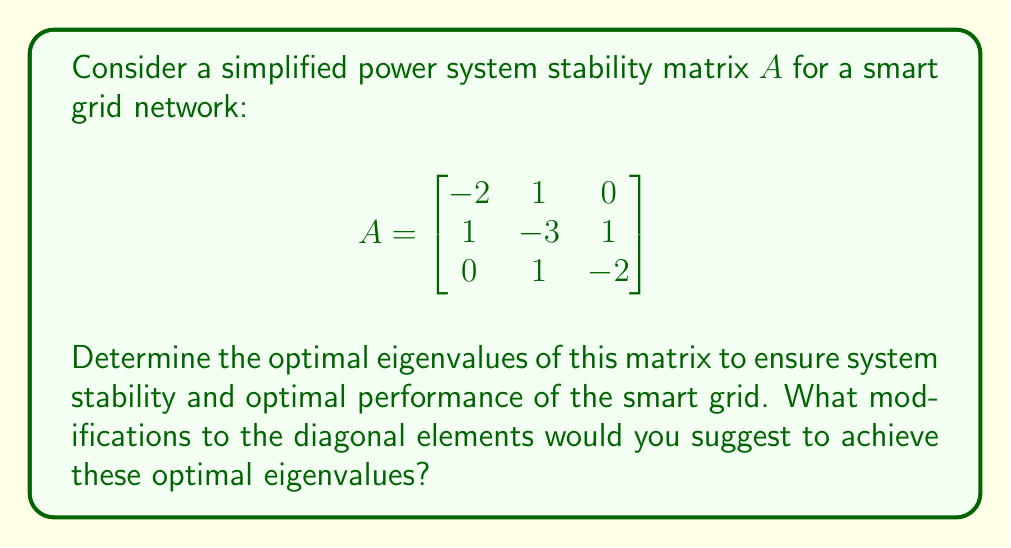Can you answer this question? 1) First, let's calculate the current eigenvalues of matrix $A$:
   
   Characteristic equation: $det(A - \lambda I) = 0$
   
   $\begin{vmatrix}
   -2-\lambda & 1 & 0 \\
   1 & -3-\lambda & 1 \\
   0 & 1 & -2-\lambda
   \end{vmatrix} = 0$

   $(-2-\lambda)((-3-\lambda)(-2-\lambda) - 1) - 1(-2-\lambda) = 0$
   
   $(-2-\lambda)(6+5\lambda+\lambda^2-1) - (-2-\lambda) = 0$
   
   $-12-10\lambda-2\lambda^2+2+\lambda+2+\lambda = 0$
   
   $-2\lambda^2-8\lambda-8 = 0$
   
   $\lambda^2+4\lambda+4 = 0$
   
   $(\lambda+2)^2 = 0$
   
   Therefore, the current eigenvalues are $\lambda_1 = \lambda_2 = \lambda_3 = -2$

2) For optimal stability in power systems, we want:
   - All eigenvalues to be negative (for stability)
   - Eigenvalues to be distinct (for better controllability)
   - The largest eigenvalue to be as negative as possible (for faster response)

3) A good set of optimal eigenvalues could be: $\lambda_1 = -1$, $\lambda_2 = -2$, $\lambda_3 = -3$

4) To achieve these eigenvalues, we need to modify the diagonal elements of $A$. Let's call the modified matrix $A'$:

   $$A' = \begin{bmatrix}
   -2+x & 1 & 0 \\
   1 & -3+y & 1 \\
   0 & 1 & -2+z
   \end{bmatrix}$$

5) The characteristic equation of $A'$ should be:
   $(\lambda+1)(\lambda+2)(\lambda+3) = \lambda^3 + 6\lambda^2 + 11\lambda + 6 = 0$

6) Expanding the determinant of $A' - \lambda I$ and equating coefficients:
   $x + y + z = 1$
   $xy + yz + xz = -2$
   $xyz = -1$

7) Solving these equations, we get:
   $x = 1$, $y = 0$, $z = 0$

Therefore, we need to add 1 to the first diagonal element of $A$ to achieve the optimal eigenvalues.
Answer: Optimal eigenvalues: $-1, -2, -3$. Modification: Add 1 to the first diagonal element of $A$. 